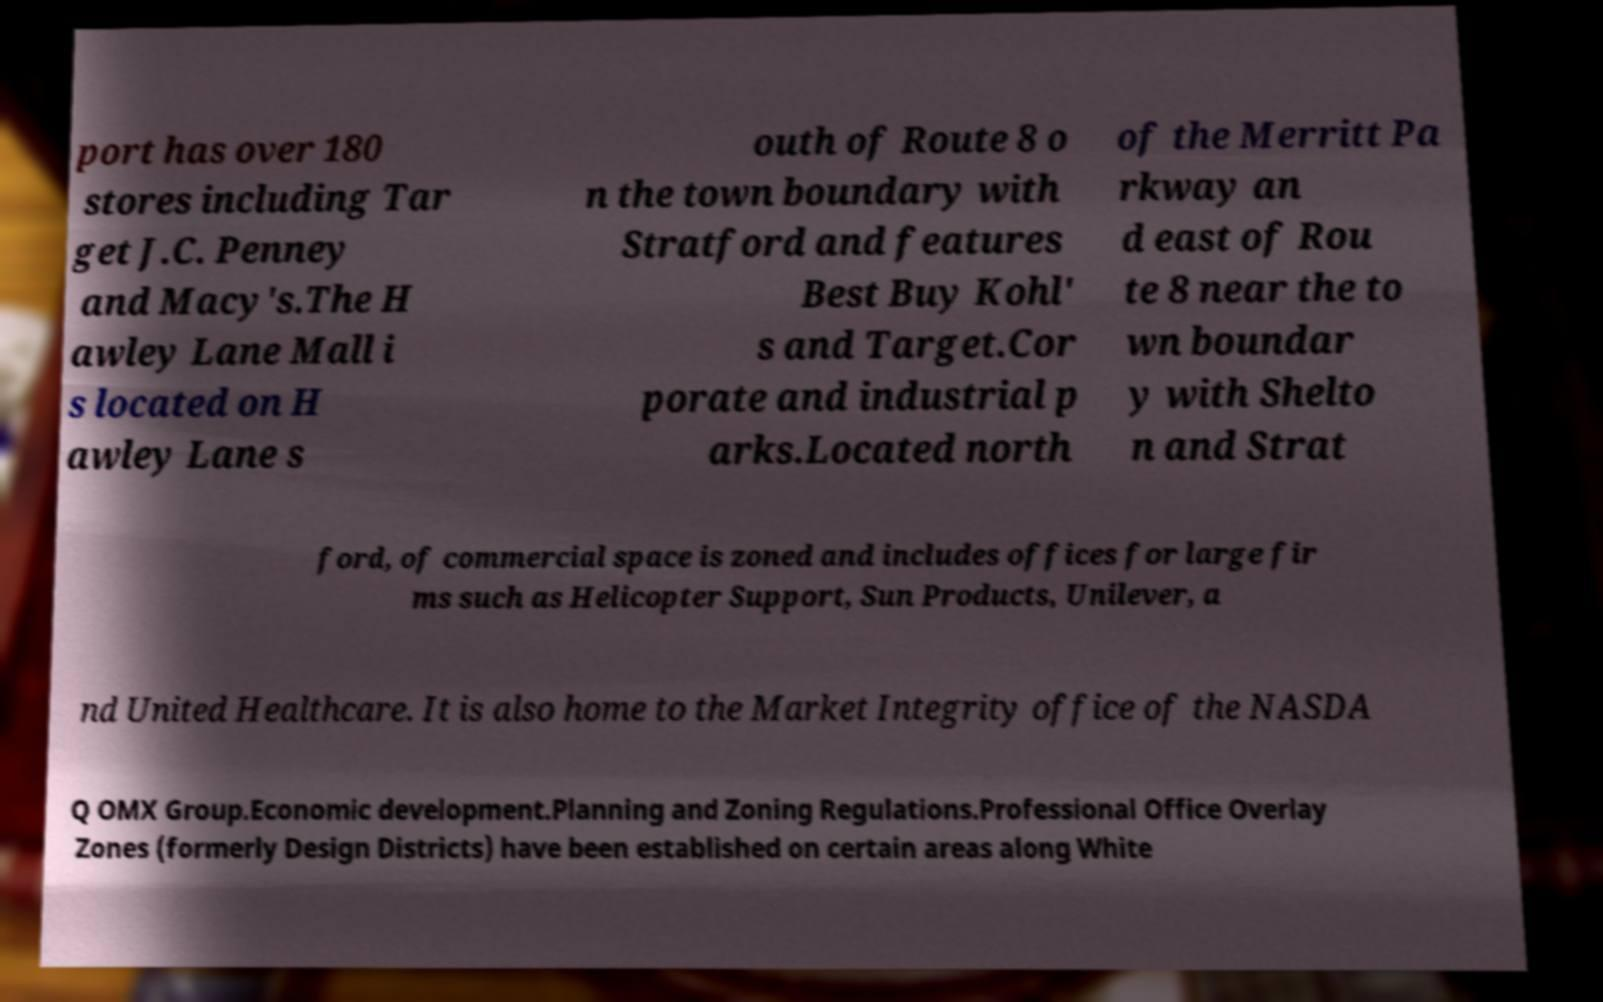For documentation purposes, I need the text within this image transcribed. Could you provide that? port has over 180 stores including Tar get J.C. Penney and Macy's.The H awley Lane Mall i s located on H awley Lane s outh of Route 8 o n the town boundary with Stratford and features Best Buy Kohl' s and Target.Cor porate and industrial p arks.Located north of the Merritt Pa rkway an d east of Rou te 8 near the to wn boundar y with Shelto n and Strat ford, of commercial space is zoned and includes offices for large fir ms such as Helicopter Support, Sun Products, Unilever, a nd United Healthcare. It is also home to the Market Integrity office of the NASDA Q OMX Group.Economic development.Planning and Zoning Regulations.Professional Office Overlay Zones (formerly Design Districts) have been established on certain areas along White 